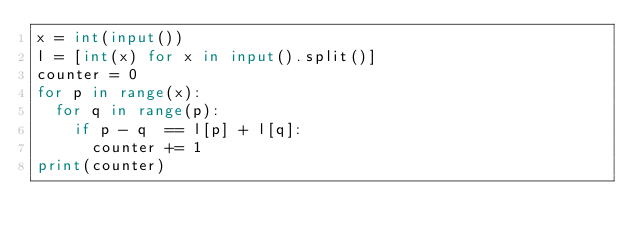<code> <loc_0><loc_0><loc_500><loc_500><_Python_>x = int(input())
l = [int(x) for x in input().split()]
counter = 0
for p in range(x):
  for q in range(p):
    if p - q  == l[p] + l[q]:
      counter += 1
print(counter)</code> 